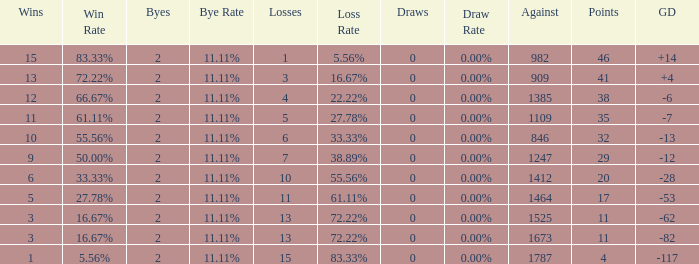What is the average number of Byes when there were less than 0 losses and were against 1247? None. 